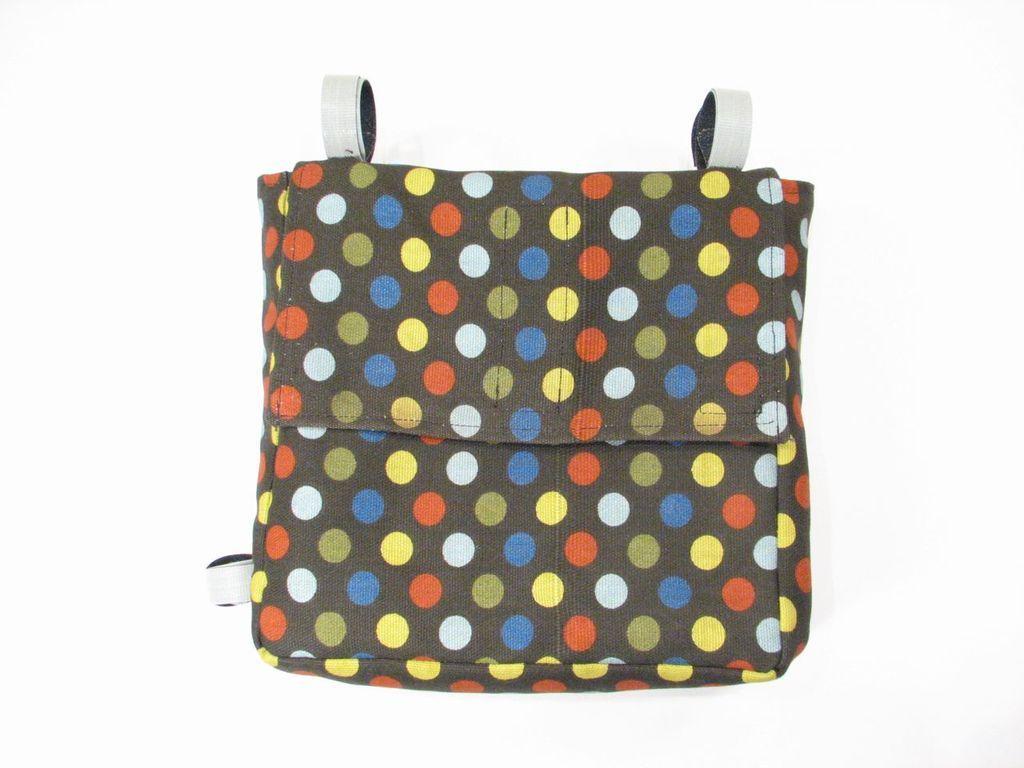How would you summarize this image in a sentence or two? A bag is shown in the picture. There is are colorful dots on the bag. It has white stripes. 